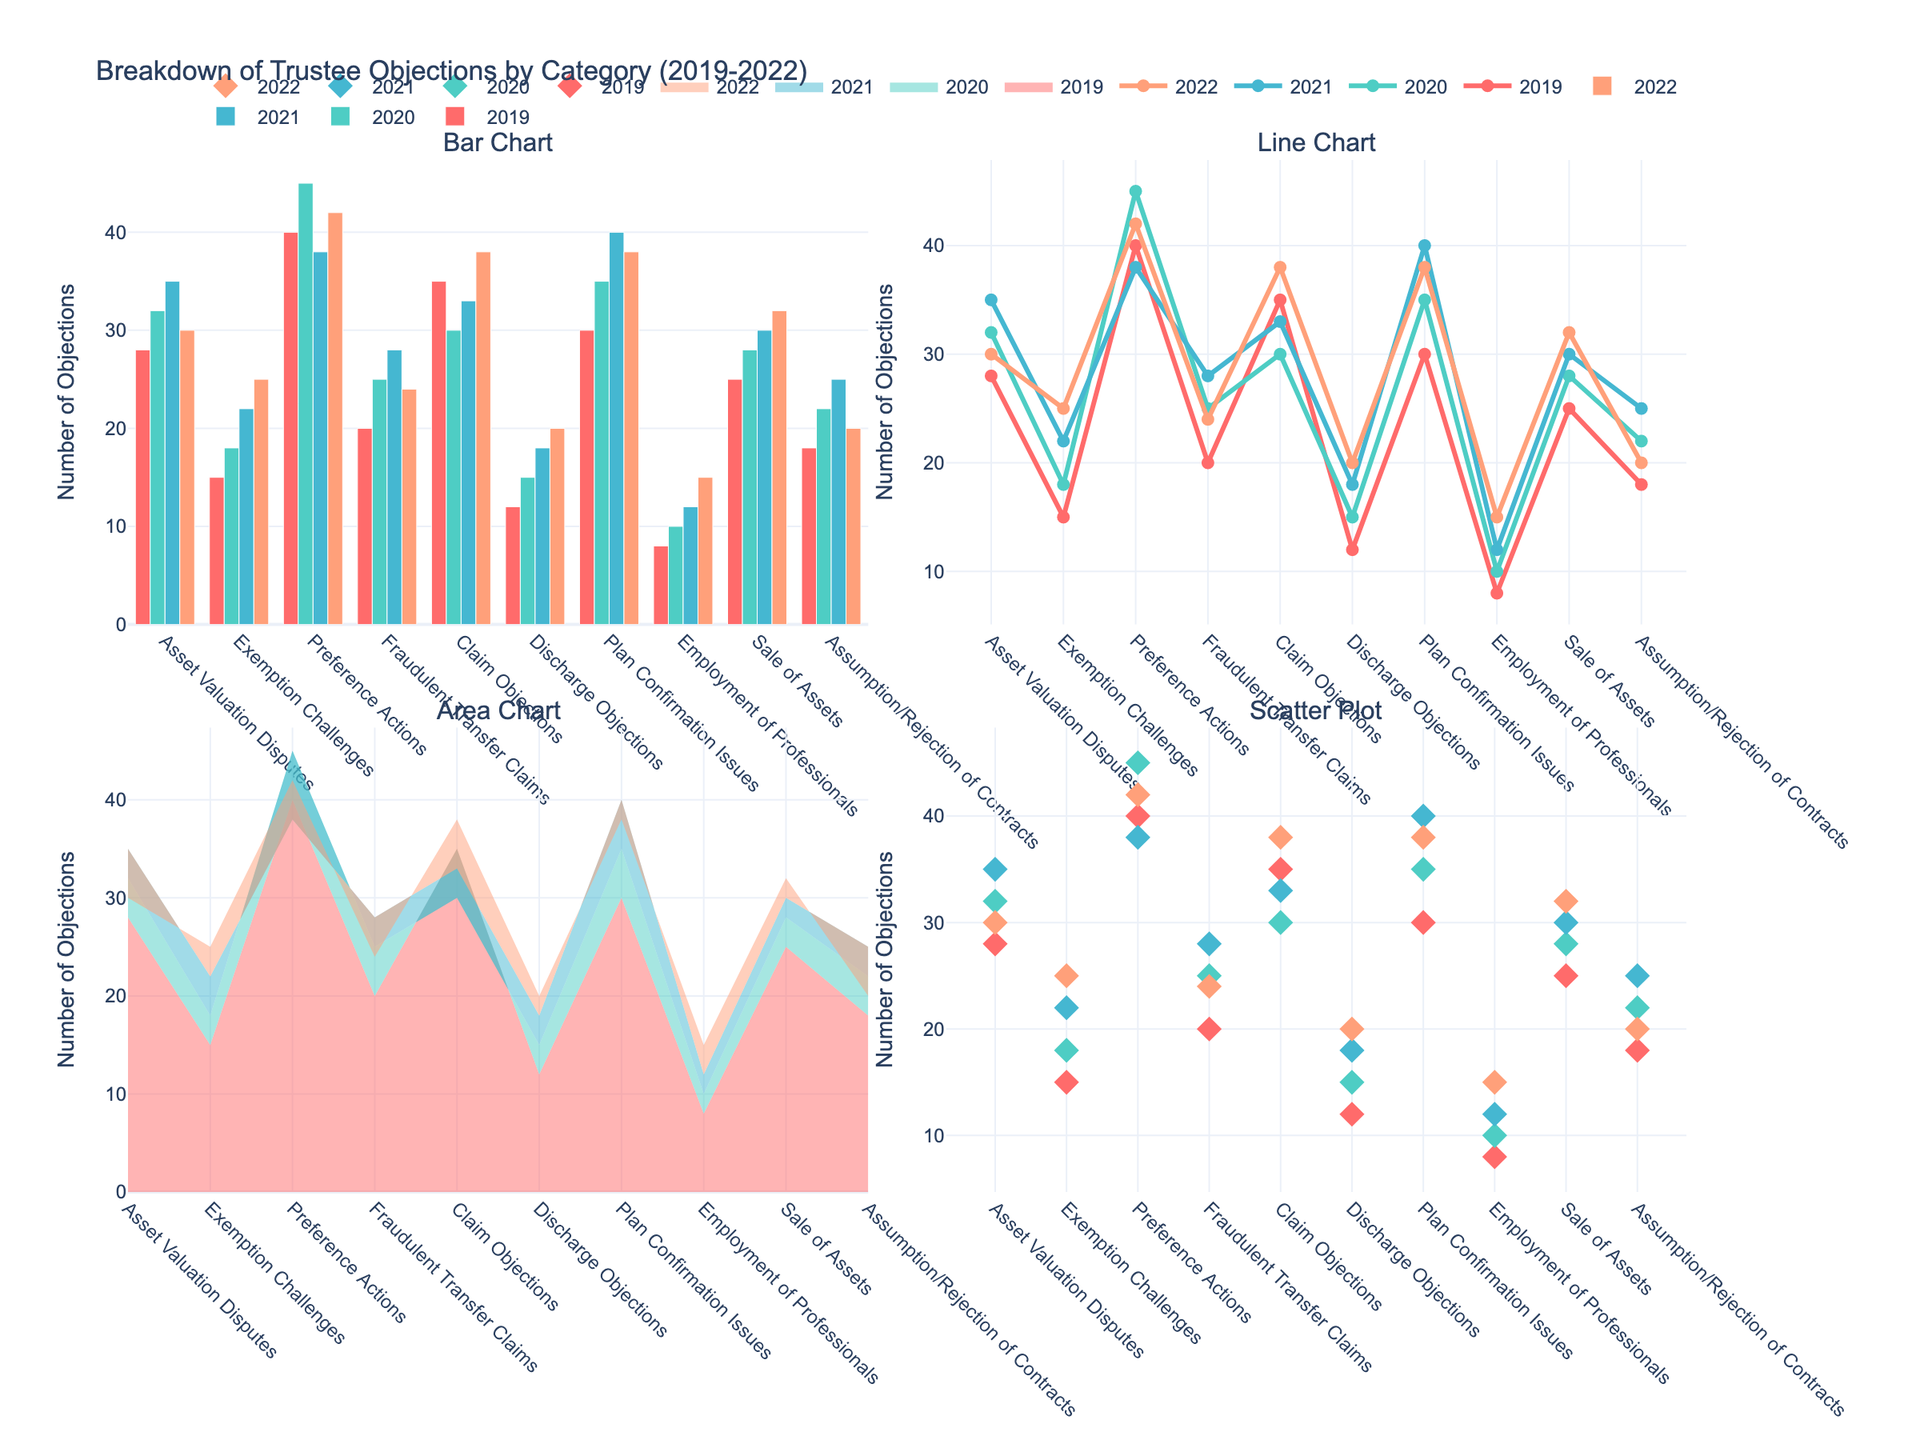What is the title of the figure? The title is displayed at the top of the figure and provides a high-level summary of the content.
Answer: Student Retention Rates: Traditional vs Reenactment Which retention rate is higher for Cell Biology after 1 month? Compare the retention rates of "Traditional_1month" and "Reenactment_1month" in the Cell Biology subplot.
Answer: Traditional What are the x-axis labels in each subplot? The x-axis labels are shown at the bottom of each subplot and indicate the time periods over which retention rates were measured.
Answer: 1 month, 6 months, 1 year How does the retention rate for Chemistry change over time for both teaching methods? Track the lines for Chemistry in both teaching methods and observe how the rates decrease over the three time periods.
Answer: Both decrease, Reenactment has a slower decline Which subject shows the largest decrease in retention rate in the Traditional method from 1 month to 1 year? Calculate the difference between the retention rates at 1 month and 1 year for each subject under the Traditional method, then find the largest difference.
Answer: Geology Are the retention rates for Reenactment teaching method higher than the Traditional method after 6 months for all subjects? Compare Reenactment_6months and Traditional_6months data points for each subject.
Answer: Yes Which teaching method generally exhibits higher retention rates after 1 year across all subjects? Compare the data series for each subject at the 1-year mark for both methods.
Answer: Reenactment How does the retention rate for Astronomy after 6 months compare between Traditional and Reenactment methods? Observe the retention rate for Astronomy at the 6-month mark for both methods on the graph.
Answer: Reenactment is higher Which subject has the smallest retention gap between the two teaching methods at the 1-month mark? Calculate the difference between Traditional_1month and Reenactment_1month for each subject and find the smallest value.
Answer: Cell Biology 